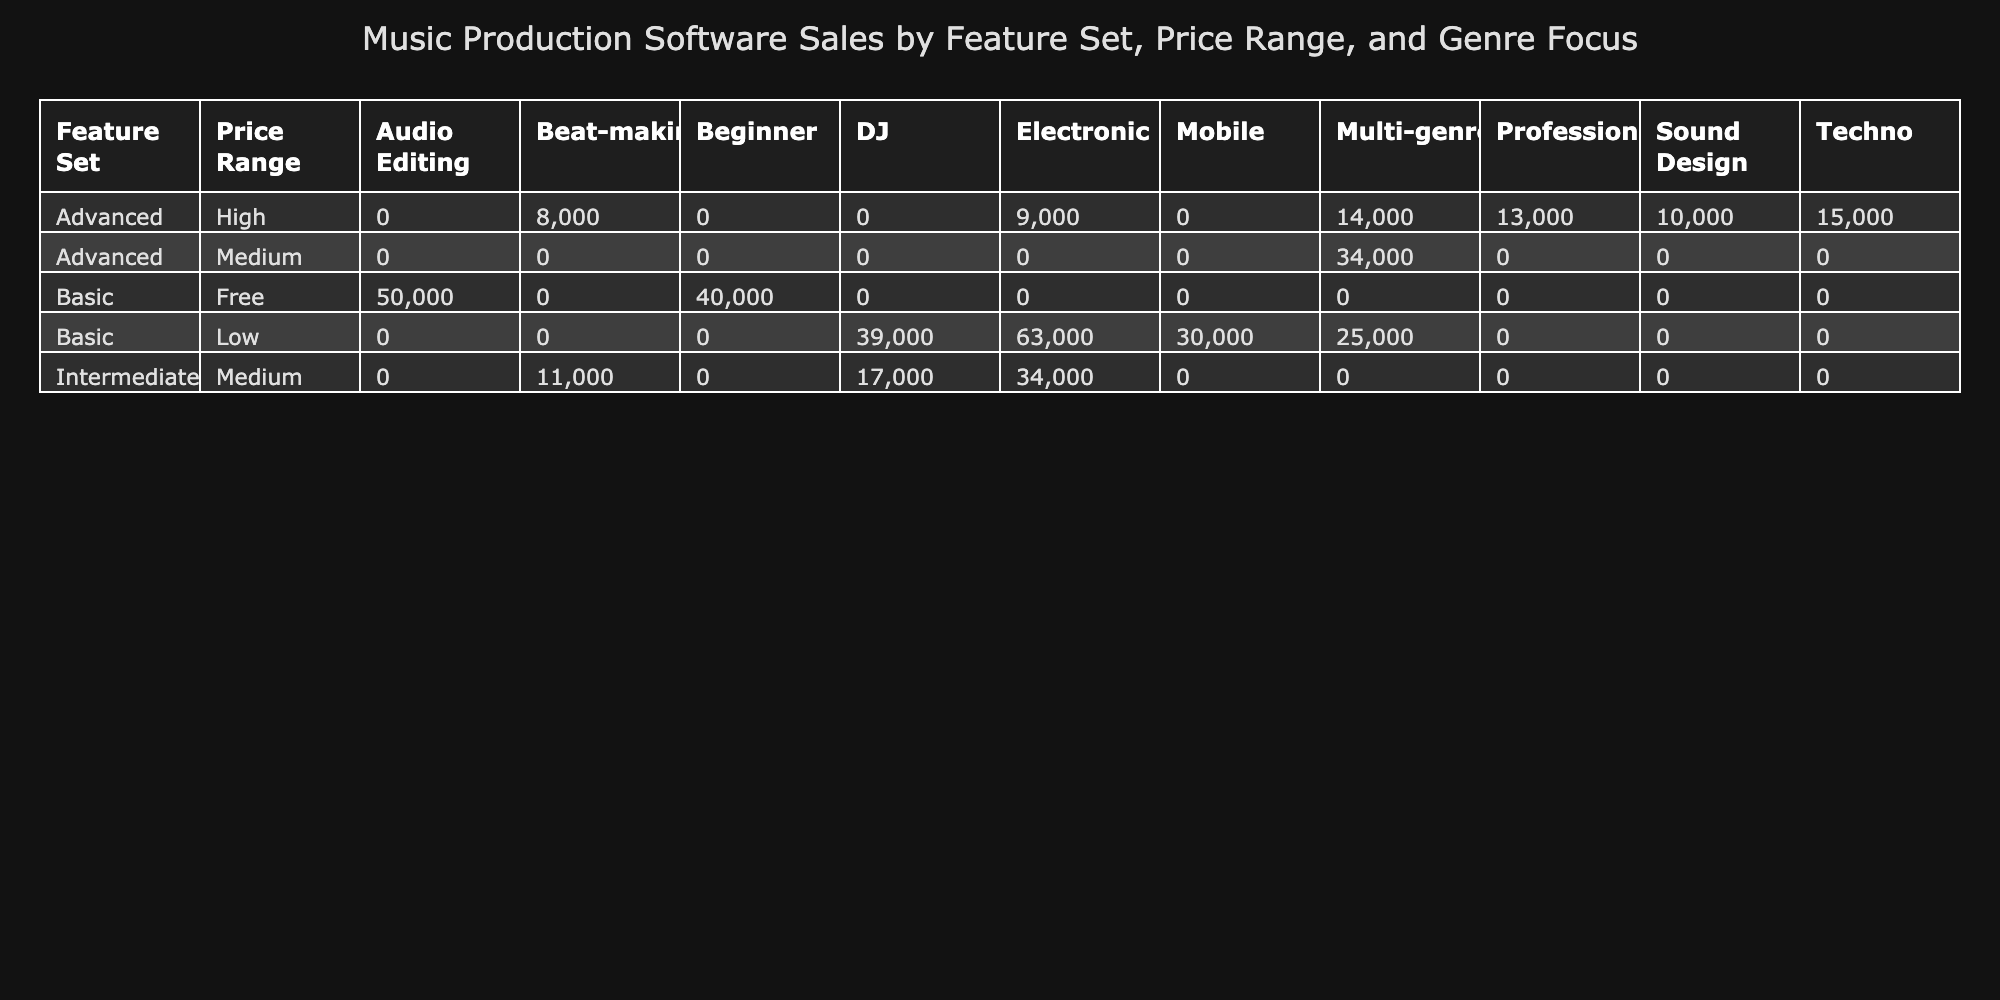What is the total number of units sold for music production software categorized as Advanced in the High price range? The table indicates the following Advanced software in the High price range: Ableton Live (15,000), Cubase (14,000), and Pro Tools (13,000). Adding these values gives 15,000 + 14,000 + 13,000 = 42,000.
Answer: 42,000 How many units were sold for software with a Basic feature set and a Low price range? The Basic software in the Low price range includes Reaper (25,000), Traktor (20,000), Serato DJ (19,000), and Fruity Loops Mobile (30,000). Summing these gives 25,000 + 20,000 + 19,000 + 30,000 = 94,000.
Answer: 94,000 Is the average user rating higher for Intermediate software compared to Basic software? The User Ratings for Intermediate software are: FL Studio (4.6), Reason (4.3), and rekordbox (4.0), which average to (4.6 + 4.3 + 4.0) / 3 = 4.30. For Basic software: Reaper (4.4), Traktor (4.1), Serato DJ (4.3), Audacity (4.2), GarageBand (4.0), Fruity Loops Mobile (3.9), Ableton Live Lite (4.3), averaging (4.4 + 4.1 + 4.3 + 4.2 + 4.0 + 3.9 + 4.3) / 8 = 4.16. Thus, the average user rating for Intermediate (4.30) is higher than for Basic (4.16).
Answer: Yes Which Genre Focus has the highest total unit sales across all feature sets? To determine this, we sum units sold across each genre: Techno (15,000), Electronic (22,000 + 9,000 + 12,000 + 11,000 + 8,000 + 28,000), Multi-genre (18,000 + 14,000 + 16,000), DJ (20,000 + 19,000 + 17,000), Professional (13,000), Beat-making (8,000 + 10,000), and Audio Editing (50,000). Calculating gives us: Techno (15,000), Electronic (22,000 + 9,000 + 12,000 + 11,000 + 8,000 + 28,000 = 90,000), Multi-genre (18,000 + 14,000 + 16,000 = 48,000), DJ (20,000 + 19,000 + 17,000 = 56,000), Professional (13,000), Beat-making (18,000), Audio Editing (50,000). The highest is Electronic (90,000).
Answer: Electronic What is the user rating for the software with the lowest units sold in the Advanced feature set? Among Advanced software, the lowest units sold is Bitwig Studio (9,000), which has a user rating of 4.5.
Answer: 4.5 